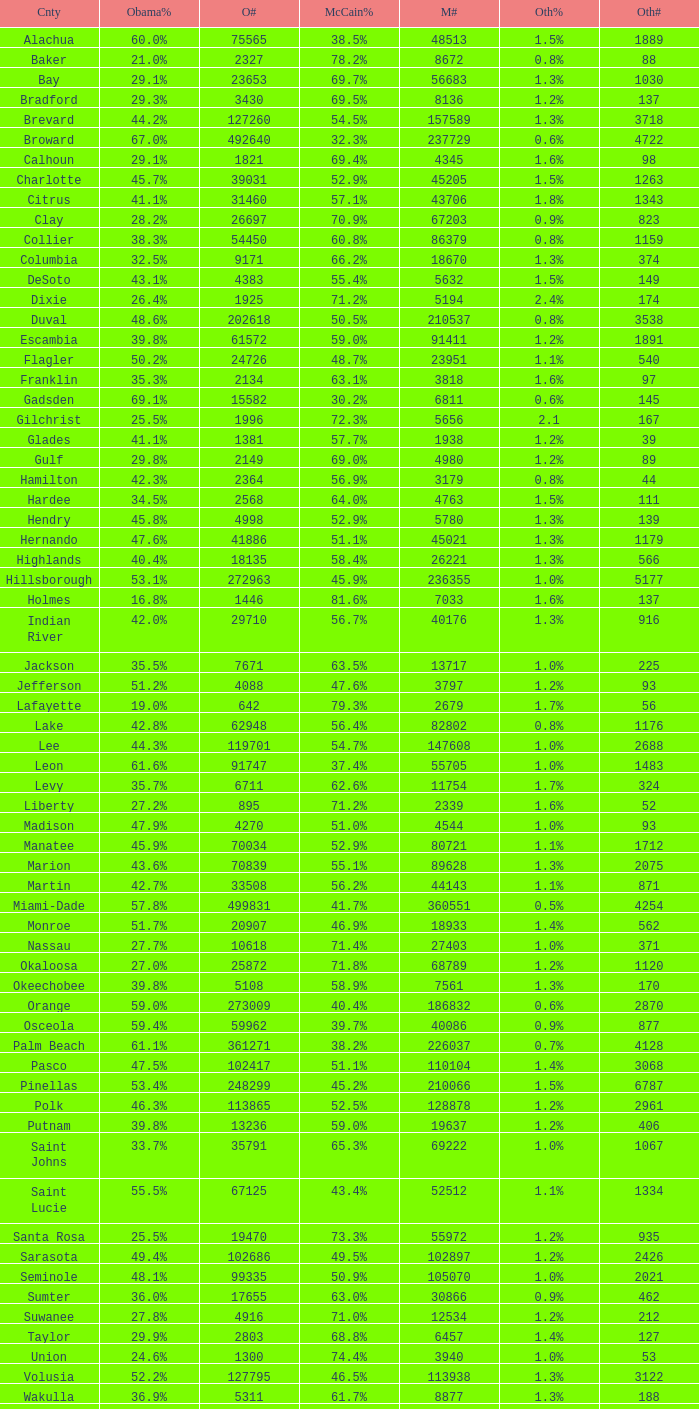What was the number of others votes in Columbia county? 374.0. 